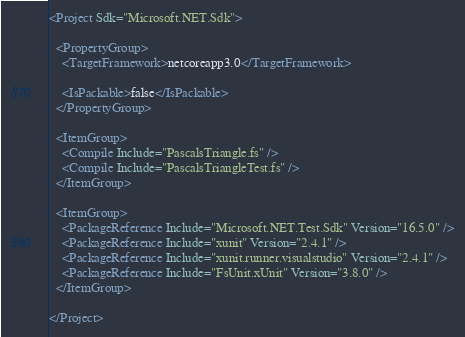<code> <loc_0><loc_0><loc_500><loc_500><_XML_><Project Sdk="Microsoft.NET.Sdk">

  <PropertyGroup>
    <TargetFramework>netcoreapp3.0</TargetFramework>

    <IsPackable>false</IsPackable>
  </PropertyGroup>

  <ItemGroup>
    <Compile Include="PascalsTriangle.fs" />
    <Compile Include="PascalsTriangleTest.fs" />
  </ItemGroup>

  <ItemGroup>
    <PackageReference Include="Microsoft.NET.Test.Sdk" Version="16.5.0" />
    <PackageReference Include="xunit" Version="2.4.1" />
    <PackageReference Include="xunit.runner.visualstudio" Version="2.4.1" />
    <PackageReference Include="FsUnit.xUnit" Version="3.8.0" />
  </ItemGroup>

</Project>
</code> 